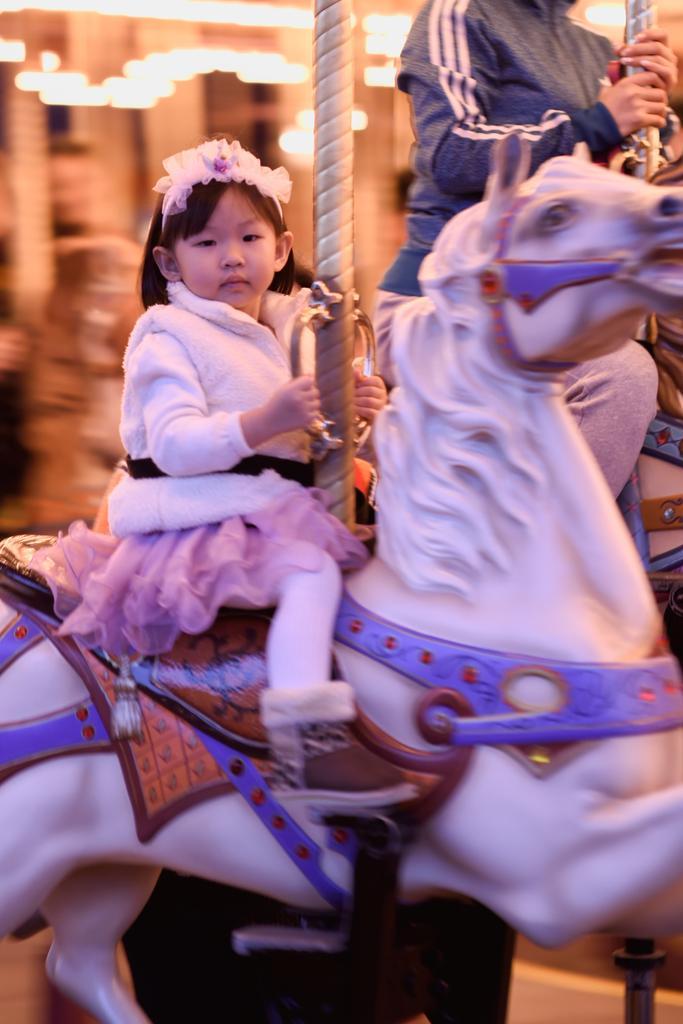Please provide a concise description of this image. In this image I see a child who is sitting on a toy horse and in the background I see another person. 